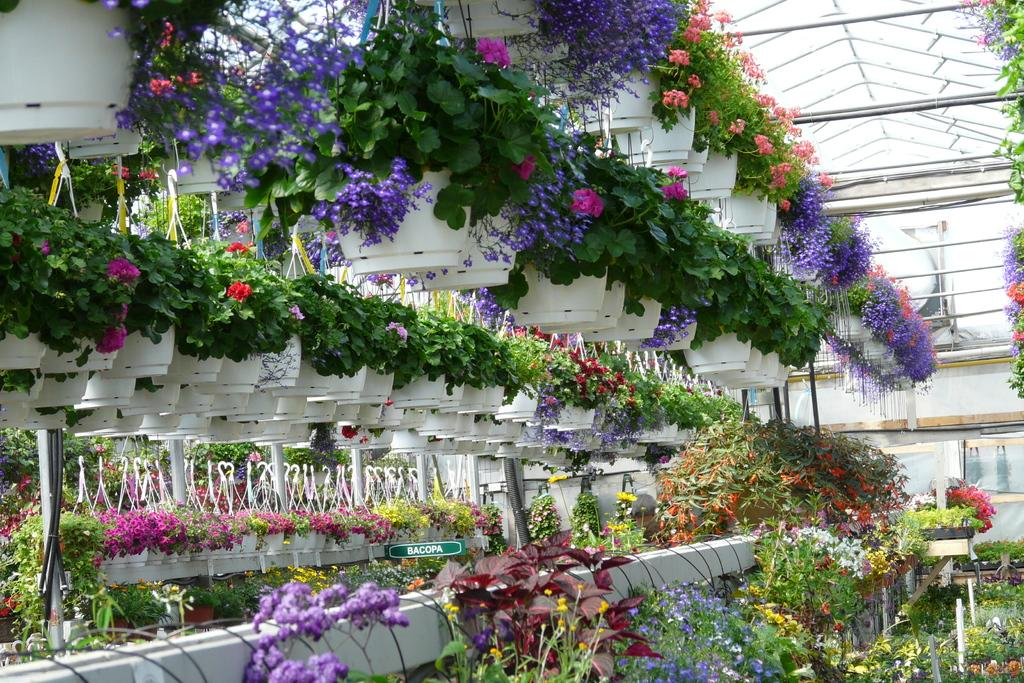What type of plants are in the image? There are artificial plants in the image. How are the artificial plants arranged or displayed? The artificial plants are in pots. What additional features can be seen on the artificial plants? There are flowers on the artificial plants. What type of animal can be seen in the mine in the image? There is no animal or mine present in the image; it features artificial plants in pots with flowers. 